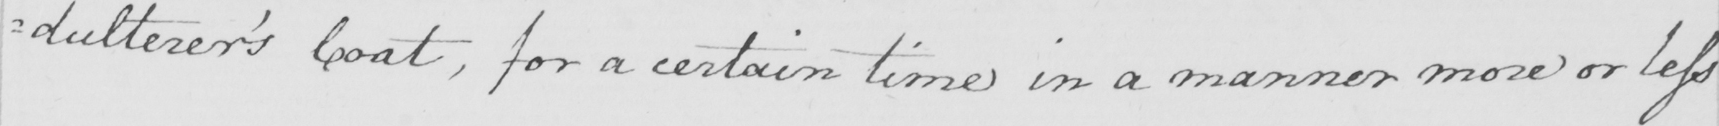Transcribe the text shown in this historical manuscript line. =dulterer ' s Coat , for a certain time in a manner more or less 